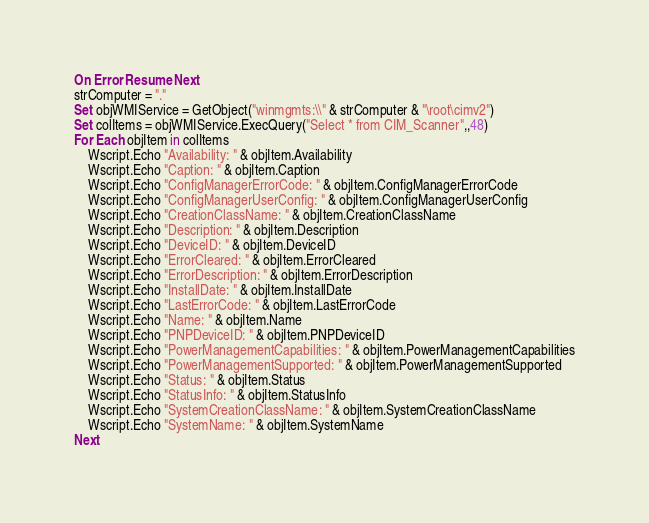Convert code to text. <code><loc_0><loc_0><loc_500><loc_500><_VisualBasic_>On Error Resume Next
strComputer = "."
Set objWMIService = GetObject("winmgmts:\\" & strComputer & "\root\cimv2")
Set colItems = objWMIService.ExecQuery("Select * from CIM_Scanner",,48)
For Each objItem in colItems
    Wscript.Echo "Availability: " & objItem.Availability
    Wscript.Echo "Caption: " & objItem.Caption
    Wscript.Echo "ConfigManagerErrorCode: " & objItem.ConfigManagerErrorCode
    Wscript.Echo "ConfigManagerUserConfig: " & objItem.ConfigManagerUserConfig
    Wscript.Echo "CreationClassName: " & objItem.CreationClassName
    Wscript.Echo "Description: " & objItem.Description
    Wscript.Echo "DeviceID: " & objItem.DeviceID
    Wscript.Echo "ErrorCleared: " & objItem.ErrorCleared
    Wscript.Echo "ErrorDescription: " & objItem.ErrorDescription
    Wscript.Echo "InstallDate: " & objItem.InstallDate
    Wscript.Echo "LastErrorCode: " & objItem.LastErrorCode
    Wscript.Echo "Name: " & objItem.Name
    Wscript.Echo "PNPDeviceID: " & objItem.PNPDeviceID
    Wscript.Echo "PowerManagementCapabilities: " & objItem.PowerManagementCapabilities
    Wscript.Echo "PowerManagementSupported: " & objItem.PowerManagementSupported
    Wscript.Echo "Status: " & objItem.Status
    Wscript.Echo "StatusInfo: " & objItem.StatusInfo
    Wscript.Echo "SystemCreationClassName: " & objItem.SystemCreationClassName
    Wscript.Echo "SystemName: " & objItem.SystemName
Next

</code> 